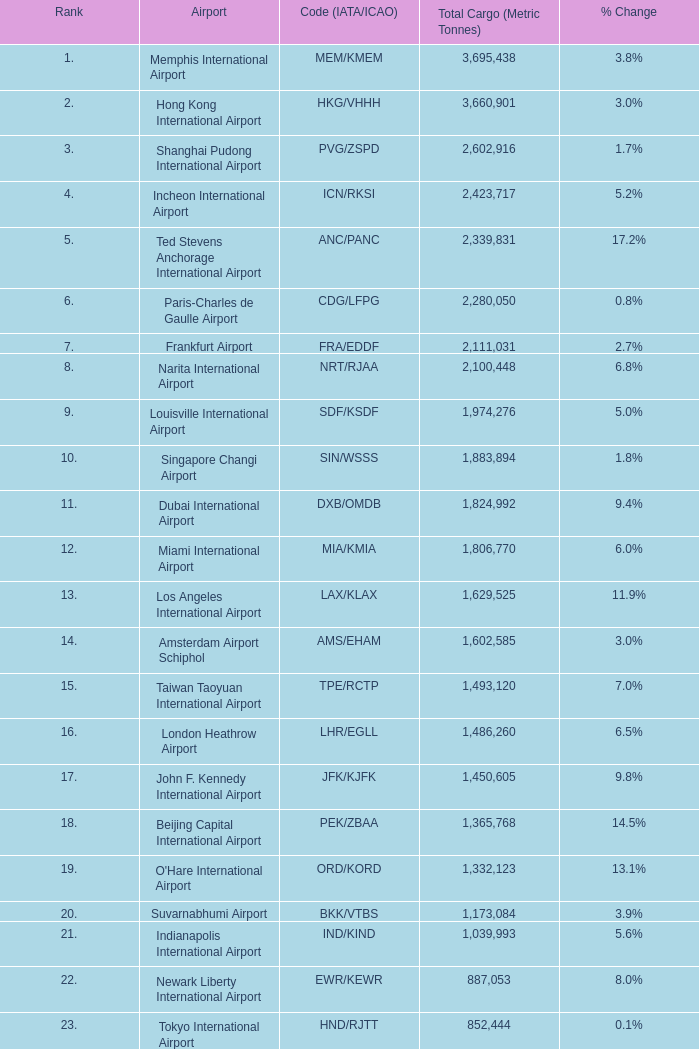What is the rank for ord/kord with more than 1,332,123 total cargo? None. 